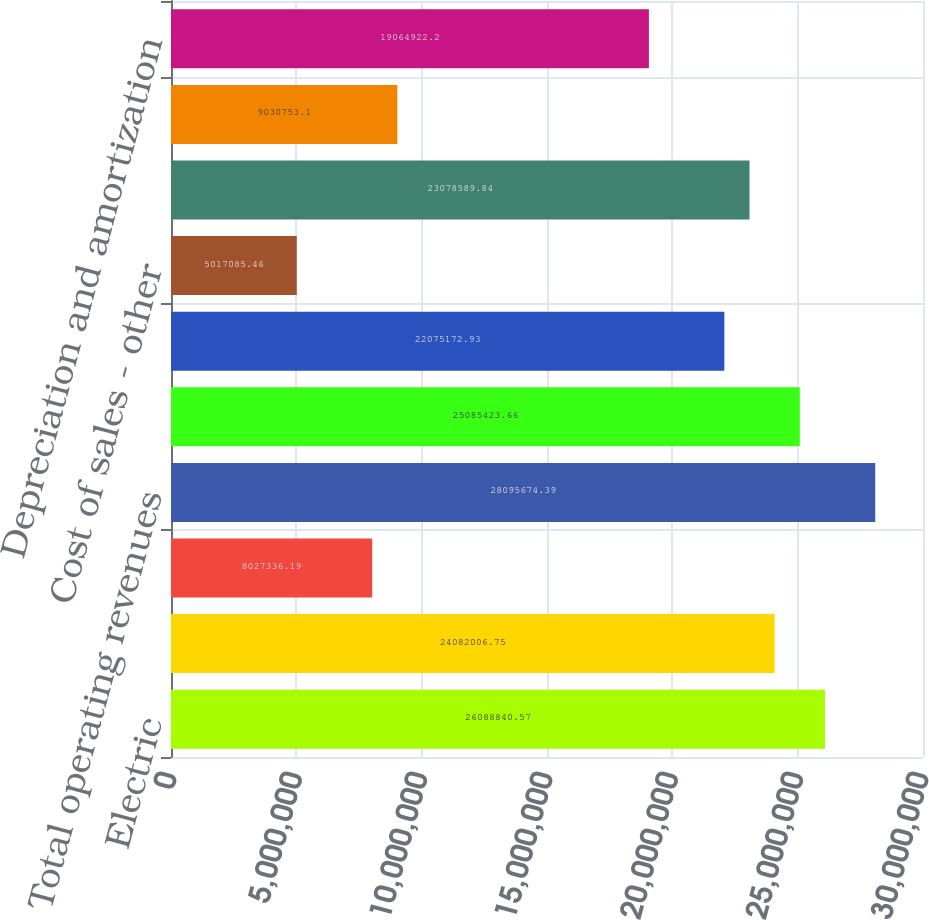<chart> <loc_0><loc_0><loc_500><loc_500><bar_chart><fcel>Electric<fcel>Natural gas<fcel>Other<fcel>Total operating revenues<fcel>Electric fuel and purchased<fcel>Cost of natural gas sold and<fcel>Cost of sales - other<fcel>Other operating and<fcel>Conservation and demand-side<fcel>Depreciation and amortization<nl><fcel>2.60888e+07<fcel>2.4082e+07<fcel>8.02734e+06<fcel>2.80957e+07<fcel>2.50854e+07<fcel>2.20752e+07<fcel>5.01709e+06<fcel>2.30786e+07<fcel>9.03075e+06<fcel>1.90649e+07<nl></chart> 